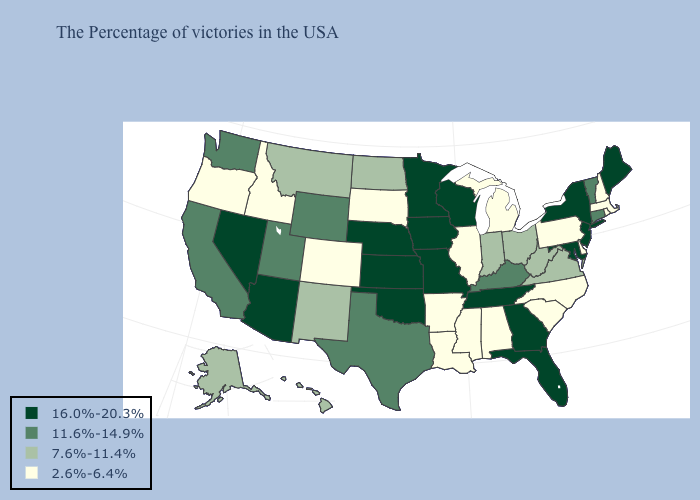What is the lowest value in the USA?
Write a very short answer. 2.6%-6.4%. Among the states that border West Virginia , which have the highest value?
Keep it brief. Maryland. Does New Mexico have the highest value in the West?
Give a very brief answer. No. Does the map have missing data?
Answer briefly. No. Does the map have missing data?
Answer briefly. No. Which states have the lowest value in the Northeast?
Quick response, please. Massachusetts, Rhode Island, New Hampshire, Pennsylvania. Is the legend a continuous bar?
Give a very brief answer. No. Name the states that have a value in the range 16.0%-20.3%?
Give a very brief answer. Maine, New York, New Jersey, Maryland, Florida, Georgia, Tennessee, Wisconsin, Missouri, Minnesota, Iowa, Kansas, Nebraska, Oklahoma, Arizona, Nevada. What is the lowest value in the USA?
Write a very short answer. 2.6%-6.4%. Does Maryland have the lowest value in the South?
Short answer required. No. Which states have the highest value in the USA?
Answer briefly. Maine, New York, New Jersey, Maryland, Florida, Georgia, Tennessee, Wisconsin, Missouri, Minnesota, Iowa, Kansas, Nebraska, Oklahoma, Arizona, Nevada. Among the states that border West Virginia , which have the highest value?
Keep it brief. Maryland. What is the lowest value in the Northeast?
Be succinct. 2.6%-6.4%. Is the legend a continuous bar?
Short answer required. No. Name the states that have a value in the range 7.6%-11.4%?
Give a very brief answer. Virginia, West Virginia, Ohio, Indiana, North Dakota, New Mexico, Montana, Alaska, Hawaii. 